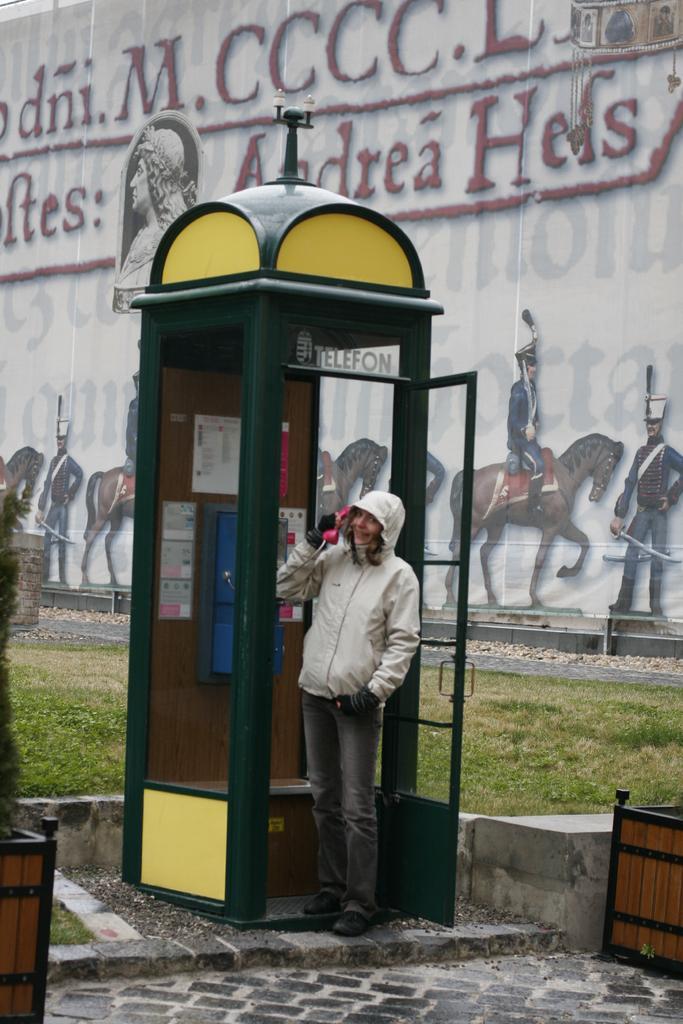Please provide a concise description of this image. There is a telephone booth and a person is talking on a phone inside the booth, behind the person there is a wall and it is painted with different images like horses and human beings and in front of the wall there is a lot of grass there are two wooden boxes kept in front of the telephone booth. 